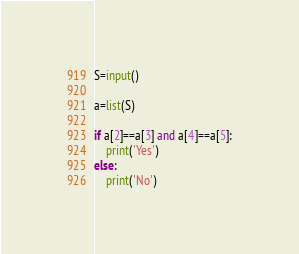<code> <loc_0><loc_0><loc_500><loc_500><_Python_>S=input()

a=list(S)

if a[2]==a[3] and a[4]==a[5]:
    print('Yes')
else:
    print('No')</code> 